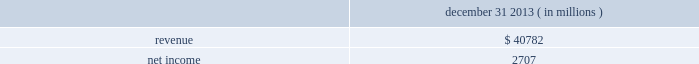Table of contents notes to consolidated financial statements of american airlines , inc .
The asset .
Projected cash flows are discounted at a required market rate of return that reflects the relative risk of achieving the cash flows and the time value of money .
The cost approach , which estimates value by determining the current cost of replacing an asset with another of equivalent economic utility , was used , as appropriate , for certain assets for which the market and income approaches could not be applied due to the nature of the asset .
The cost to replace a given asset reflects the estimated reproduction or replacement cost for the asset , less an allowance for loss in value due to depreciation .
The fair value of us airways 2019 dividend miles loyalty program liability was determined based on the weighted average equivalent ticket value of outstanding miles which were expected to be redeemed for future travel at december 9 , 2013 .
The weighted average equivalent ticket value contemplates differing classes of service , domestic and international itineraries and the carrier providing the award travel .
Pro-forma impact of the merger american 2019s unaudited pro-forma results presented below include the effects of the merger as if it had been consummated as of january 1 , 2012 .
The pro- forma results include the depreciation and amortization associated with the acquired tangible and intangible assets , lease and debt fair value adjustments , the elimination of any deferred gains or losses , adjustments relating to reflecting the fair value of the loyalty program liability and the impact of income changes on profit sharing expense , among others .
In addition , the pro-forma results below reflect the impact of higher wage rates related to memorandums of understanding with us airways 2019 pilots that became effective upon closing of the merger , as well as the elimination of american 2019s reorganization items , net and merger transition costs .
However , the pro-forma results do not include any anticipated synergies or other expected benefits of the merger .
Accordingly , the unaudited pro-forma financial information below is not necessarily indicative of either future results of operations or results that might have been achieved had the acquisition been consummated as of january 1 , 2012 .
December 31 , ( in millions ) .
Basis of presentation and summary of significant accounting policies ( a ) basis of presentation on december 30 , 2015 , us airways merged with and into american , which is reflected in american 2019s consolidated financial statements as though the transaction had occurred on december 9 , 2013 , when a subsidiary of amr merged with and into us airways group .
Thus , the full years of 2015 and 2014 and the period from december 9 , 2013 to december 31 , 2013 are comprised of the consolidated financial data of american and us airways .
For the periods prior to december 9 , 2013 , the financial data reflects the results of american only .
For financial reporting purposes , the transaction constituted a transfer of assets between entities under common control and was accounted for in a manner similar to the pooling of interests method of accounting .
Under this method , the carrying amount of net assets recognized in the balance sheets of each combining entity are carried forward to the balance sheet of the combined entity and no other assets or liabilities are recognized .
The preparation of financial statements in accordance with accounting principles generally accepted in the united states ( gaap ) requires management to make certain estimates and assumptions that affect the reported amounts of assets and liabilities , revenues and expenses , and the disclosure of contingent assets and liabilities at the date of the financial statements .
Actual results could differ from those estimates .
The most significant areas of judgment relate to passenger revenue recognition , impairment of goodwill , impairment of long-lived and .
What is the net income margin in 2013? 
Computations: (2707 / 40782)
Answer: 0.06638. Table of contents notes to consolidated financial statements of american airlines , inc .
The asset .
Projected cash flows are discounted at a required market rate of return that reflects the relative risk of achieving the cash flows and the time value of money .
The cost approach , which estimates value by determining the current cost of replacing an asset with another of equivalent economic utility , was used , as appropriate , for certain assets for which the market and income approaches could not be applied due to the nature of the asset .
The cost to replace a given asset reflects the estimated reproduction or replacement cost for the asset , less an allowance for loss in value due to depreciation .
The fair value of us airways 2019 dividend miles loyalty program liability was determined based on the weighted average equivalent ticket value of outstanding miles which were expected to be redeemed for future travel at december 9 , 2013 .
The weighted average equivalent ticket value contemplates differing classes of service , domestic and international itineraries and the carrier providing the award travel .
Pro-forma impact of the merger american 2019s unaudited pro-forma results presented below include the effects of the merger as if it had been consummated as of january 1 , 2012 .
The pro- forma results include the depreciation and amortization associated with the acquired tangible and intangible assets , lease and debt fair value adjustments , the elimination of any deferred gains or losses , adjustments relating to reflecting the fair value of the loyalty program liability and the impact of income changes on profit sharing expense , among others .
In addition , the pro-forma results below reflect the impact of higher wage rates related to memorandums of understanding with us airways 2019 pilots that became effective upon closing of the merger , as well as the elimination of american 2019s reorganization items , net and merger transition costs .
However , the pro-forma results do not include any anticipated synergies or other expected benefits of the merger .
Accordingly , the unaudited pro-forma financial information below is not necessarily indicative of either future results of operations or results that might have been achieved had the acquisition been consummated as of january 1 , 2012 .
December 31 , ( in millions ) .
Basis of presentation and summary of significant accounting policies ( a ) basis of presentation on december 30 , 2015 , us airways merged with and into american , which is reflected in american 2019s consolidated financial statements as though the transaction had occurred on december 9 , 2013 , when a subsidiary of amr merged with and into us airways group .
Thus , the full years of 2015 and 2014 and the period from december 9 , 2013 to december 31 , 2013 are comprised of the consolidated financial data of american and us airways .
For the periods prior to december 9 , 2013 , the financial data reflects the results of american only .
For financial reporting purposes , the transaction constituted a transfer of assets between entities under common control and was accounted for in a manner similar to the pooling of interests method of accounting .
Under this method , the carrying amount of net assets recognized in the balance sheets of each combining entity are carried forward to the balance sheet of the combined entity and no other assets or liabilities are recognized .
The preparation of financial statements in accordance with accounting principles generally accepted in the united states ( gaap ) requires management to make certain estimates and assumptions that affect the reported amounts of assets and liabilities , revenues and expenses , and the disclosure of contingent assets and liabilities at the date of the financial statements .
Actual results could differ from those estimates .
The most significant areas of judgment relate to passenger revenue recognition , impairment of goodwill , impairment of long-lived and .
What was the net profit margin on december 312013? 
Rationale: the net profit margin is the net income over the revenues
Computations: (2707 / 40782)
Answer: 0.06638. 